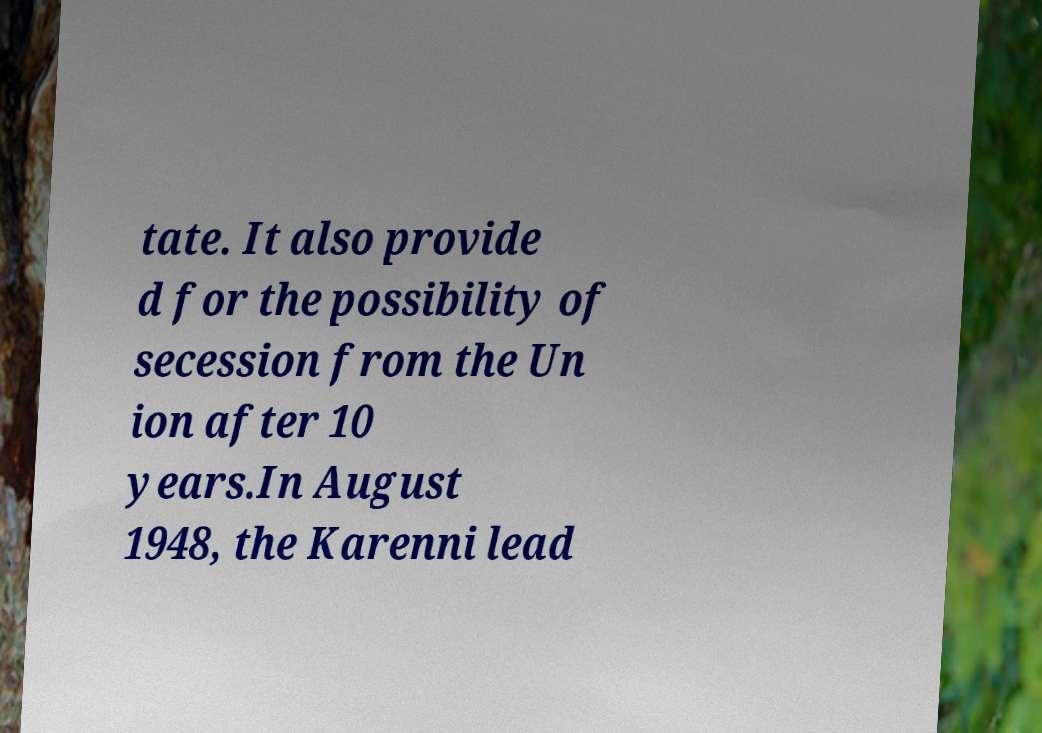Can you read and provide the text displayed in the image?This photo seems to have some interesting text. Can you extract and type it out for me? tate. It also provide d for the possibility of secession from the Un ion after 10 years.In August 1948, the Karenni lead 